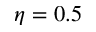Convert formula to latex. <formula><loc_0><loc_0><loc_500><loc_500>\eta = 0 . 5</formula> 